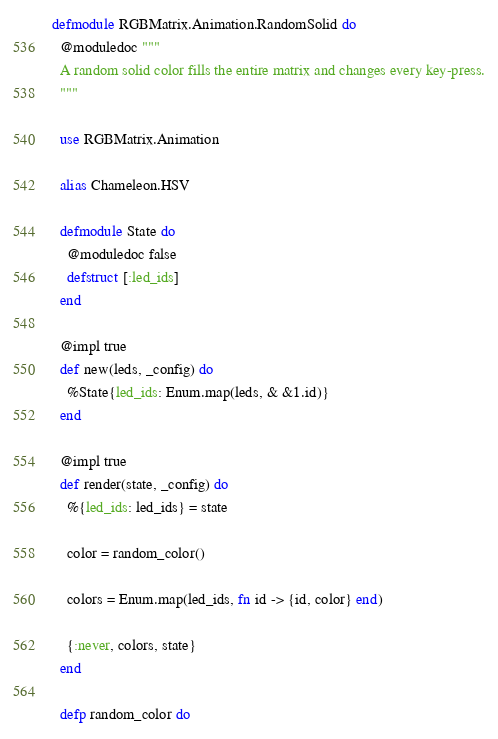<code> <loc_0><loc_0><loc_500><loc_500><_Elixir_>defmodule RGBMatrix.Animation.RandomSolid do
  @moduledoc """
  A random solid color fills the entire matrix and changes every key-press.
  """

  use RGBMatrix.Animation

  alias Chameleon.HSV

  defmodule State do
    @moduledoc false
    defstruct [:led_ids]
  end

  @impl true
  def new(leds, _config) do
    %State{led_ids: Enum.map(leds, & &1.id)}
  end

  @impl true
  def render(state, _config) do
    %{led_ids: led_ids} = state

    color = random_color()

    colors = Enum.map(led_ids, fn id -> {id, color} end)

    {:never, colors, state}
  end

  defp random_color do</code> 